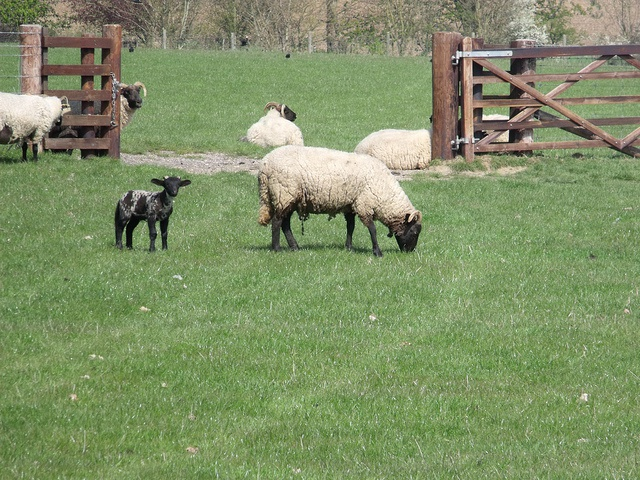Describe the objects in this image and their specific colors. I can see sheep in olive, ivory, black, tan, and gray tones, sheep in olive, ivory, darkgray, black, and gray tones, sheep in olive, black, gray, and darkgray tones, sheep in olive, ivory, tan, and darkgray tones, and sheep in olive, ivory, darkgray, lightgray, and gray tones in this image. 